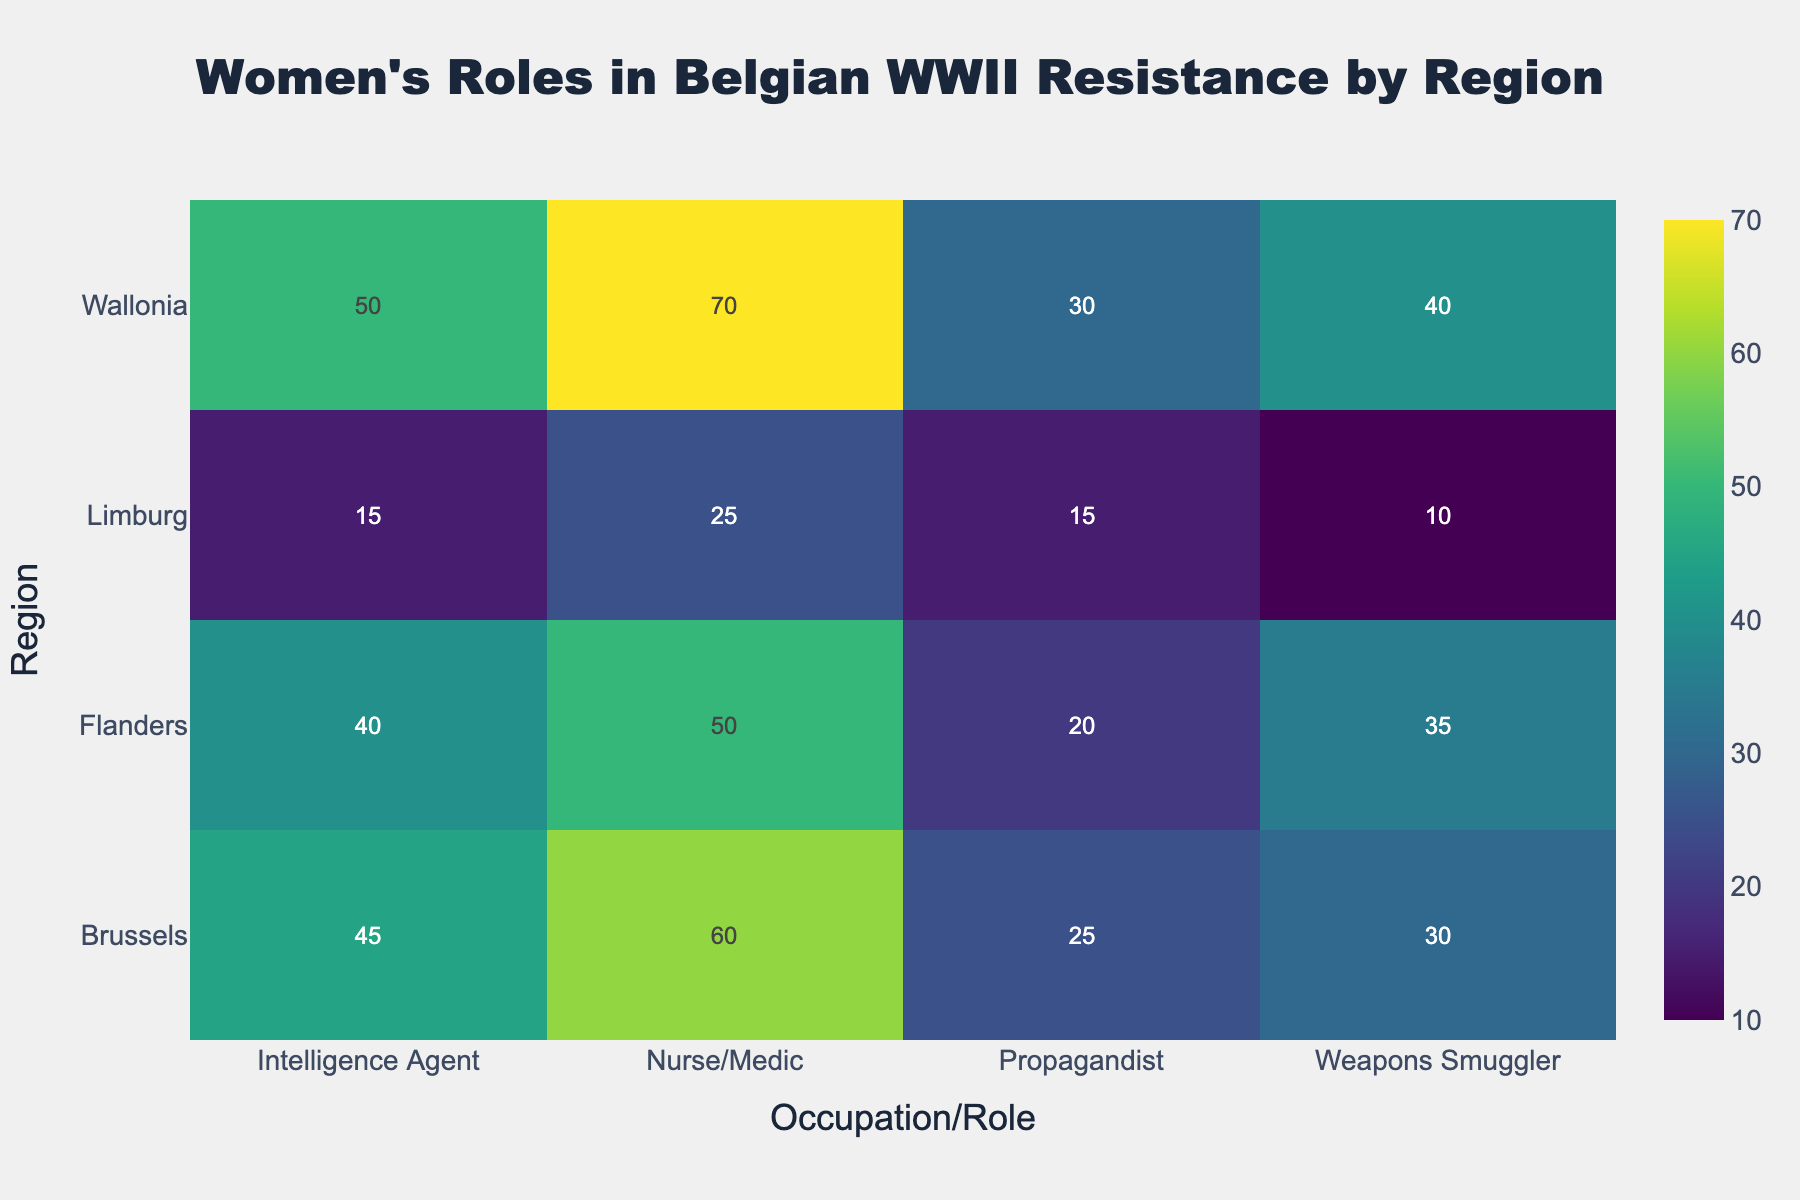What is the title of the heatmap? The title is located at the top center of the heatmap, displayed in bold, and reads "Women's Roles in Belgian WWII Resistance by Region".
Answer: Women's Roles in Belgian WWII Resistance by Region Which region has the highest number of nurses/medics in the resistance? By looking at the row corresponding to "Nurse/Medic" and finding the highest value, we see that Wallonia has 70, which is the highest.
Answer: Wallonia Which occupation/role has the lowest number in Limburg? In the row for Limburg, Weapons Smuggler has the lowest value, which is 10.
Answer: Weapons Smuggler How many intelligence agents are there in total across all regions? Add the number of intelligence agents from all regions: 45 (Brussels) + 40 (Flanders) + 50 (Wallonia) + 15 (Limburg) = 150.
Answer: 150 What is the difference in the number of propagandists between Wallonia and Limburg? Subtract the number of propagandists in Limburg (15) from the number in Wallonia (30): 30 - 15 = 15.
Answer: 15 Which region has the least variation in the number of occupations/roles? We need to visually assess the uniformity in the number of occupations/roles across a region by comparing all regions. Flanders shows relatively balanced numbers across all roles.
Answer: Flanders How does the number of weapons smugglers compare between Brussels and Wallonia? Compare the numbers directly; Brussels has 30 and Wallonia has 40, meaning Wallonia has more weapons smugglers. 40 - 30 = 10 more in Wallonia.
Answer: Wallonia has 10 more What's the average number of propagandists across all regions? Sum up the number of propagandists in all regions and divide by the number of regions: (25 + 20 + 30 + 15) / 4 = 22.5.
Answer: 22.5 Identify the region that has the highest overall involvement in occupations/roles. Sum the numbers across all roles for each region and compare. Wallonia has the highest overall number when summed up.
Answer: Wallonia 